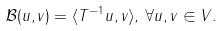Convert formula to latex. <formula><loc_0><loc_0><loc_500><loc_500>\mathcal { B } ( u , v ) = \langle T ^ { - 1 } u , v \rangle , \, \forall u , v \in V .</formula> 